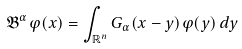<formula> <loc_0><loc_0><loc_500><loc_500>\mathfrak B ^ { \alpha } \varphi ( x ) = \int _ { \mathbb { R } ^ { n } } G _ { \alpha } ( x - y ) \varphi ( y ) \, d y</formula> 